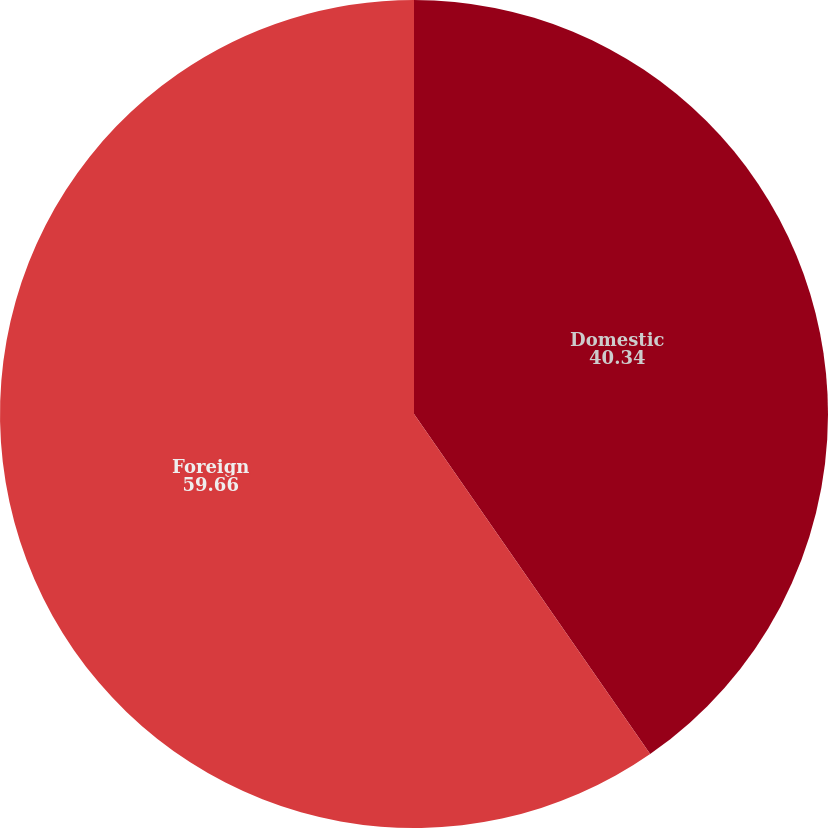Convert chart to OTSL. <chart><loc_0><loc_0><loc_500><loc_500><pie_chart><fcel>Domestic<fcel>Foreign<nl><fcel>40.34%<fcel>59.66%<nl></chart> 